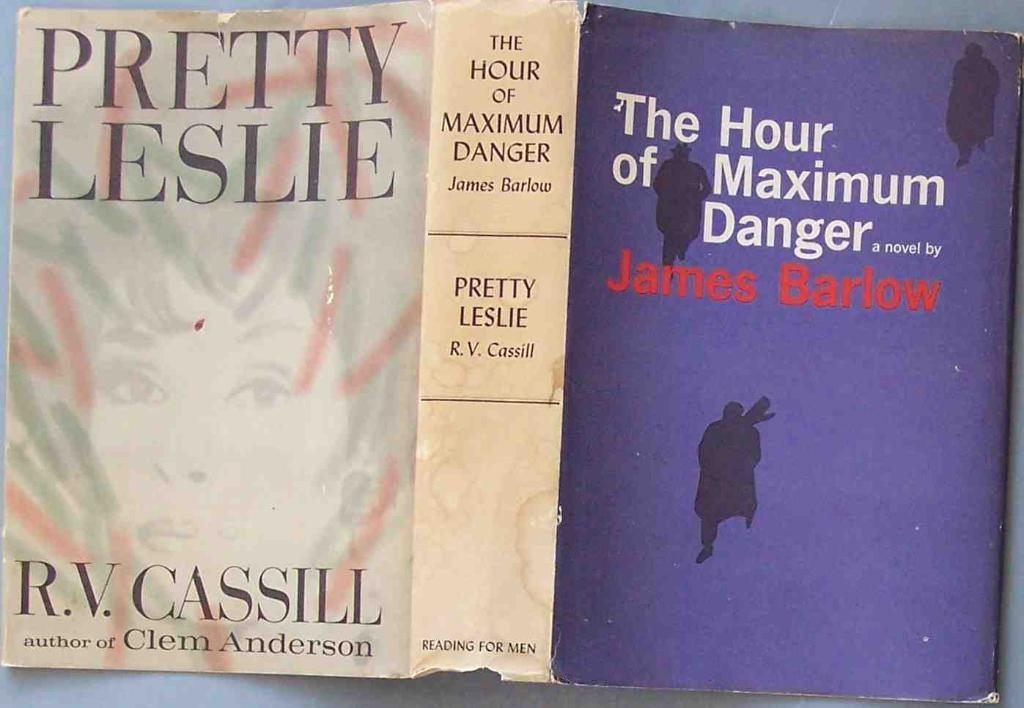<image>
Write a terse but informative summary of the picture. A used book jacket includes the title Pretty Leslie. 